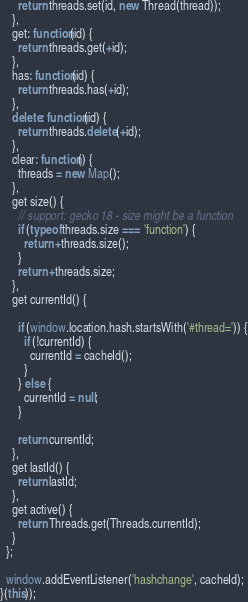<code> <loc_0><loc_0><loc_500><loc_500><_JavaScript_>      return threads.set(id, new Thread(thread));
    },
    get: function(id) {
      return threads.get(+id);
    },
    has: function(id) {
      return threads.has(+id);
    },
    delete: function(id) {
      return threads.delete(+id);
    },
    clear: function() {
      threads = new Map();
    },
    get size() {
      // support: gecko 18 - size might be a function
      if (typeof threads.size === 'function') {
        return +threads.size();
      }
      return +threads.size;
    },
    get currentId() {

      if (window.location.hash.startsWith('#thread=')) {
        if (!currentId) {
          currentId = cacheId();
        }
      } else {
        currentId = null;
      }

      return currentId;
    },
    get lastId() {
      return lastId;
    },
    get active() {
      return Threads.get(Threads.currentId);
    }
  };

  window.addEventListener('hashchange', cacheId);
}(this));
</code> 